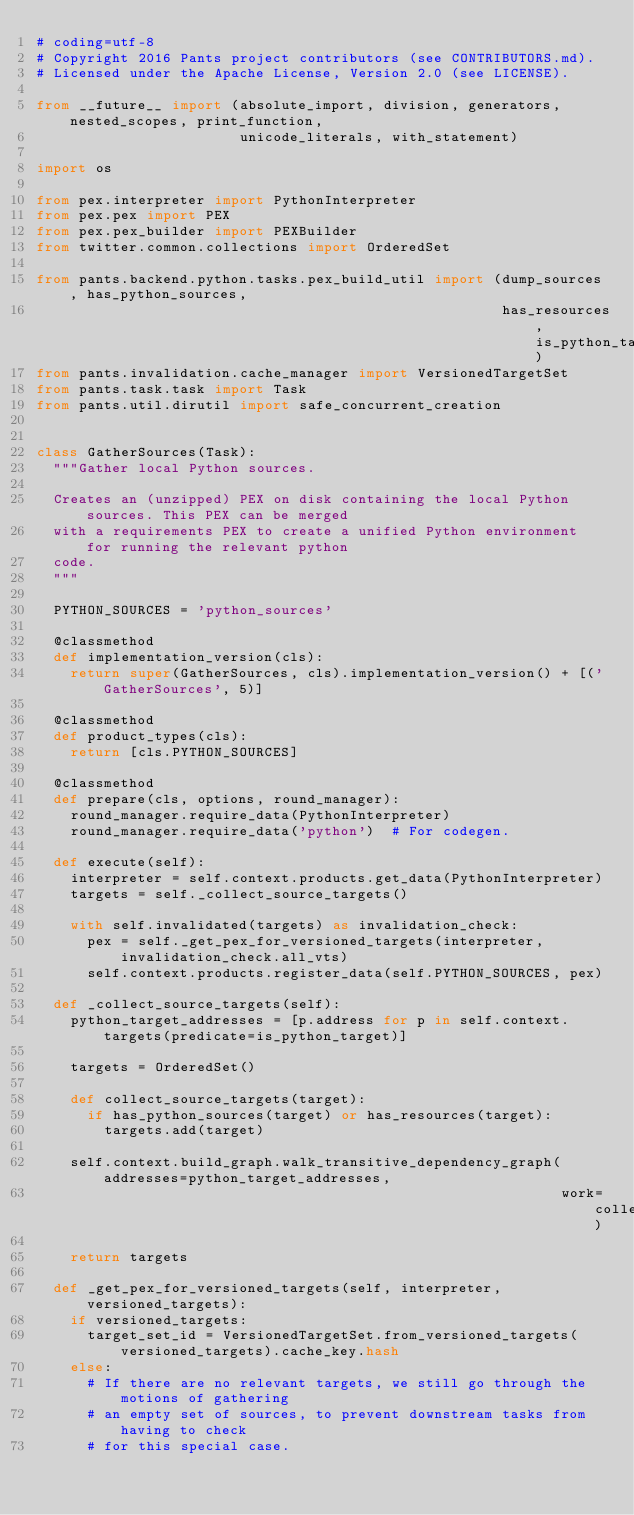Convert code to text. <code><loc_0><loc_0><loc_500><loc_500><_Python_># coding=utf-8
# Copyright 2016 Pants project contributors (see CONTRIBUTORS.md).
# Licensed under the Apache License, Version 2.0 (see LICENSE).

from __future__ import (absolute_import, division, generators, nested_scopes, print_function,
                        unicode_literals, with_statement)

import os

from pex.interpreter import PythonInterpreter
from pex.pex import PEX
from pex.pex_builder import PEXBuilder
from twitter.common.collections import OrderedSet

from pants.backend.python.tasks.pex_build_util import (dump_sources, has_python_sources,
                                                       has_resources, is_python_target)
from pants.invalidation.cache_manager import VersionedTargetSet
from pants.task.task import Task
from pants.util.dirutil import safe_concurrent_creation


class GatherSources(Task):
  """Gather local Python sources.

  Creates an (unzipped) PEX on disk containing the local Python sources. This PEX can be merged
  with a requirements PEX to create a unified Python environment for running the relevant python
  code.
  """

  PYTHON_SOURCES = 'python_sources'

  @classmethod
  def implementation_version(cls):
    return super(GatherSources, cls).implementation_version() + [('GatherSources', 5)]

  @classmethod
  def product_types(cls):
    return [cls.PYTHON_SOURCES]

  @classmethod
  def prepare(cls, options, round_manager):
    round_manager.require_data(PythonInterpreter)
    round_manager.require_data('python')  # For codegen.

  def execute(self):
    interpreter = self.context.products.get_data(PythonInterpreter)
    targets = self._collect_source_targets()

    with self.invalidated(targets) as invalidation_check:
      pex = self._get_pex_for_versioned_targets(interpreter, invalidation_check.all_vts)
      self.context.products.register_data(self.PYTHON_SOURCES, pex)

  def _collect_source_targets(self):
    python_target_addresses = [p.address for p in self.context.targets(predicate=is_python_target)]

    targets = OrderedSet()

    def collect_source_targets(target):
      if has_python_sources(target) or has_resources(target):
        targets.add(target)

    self.context.build_graph.walk_transitive_dependency_graph(addresses=python_target_addresses,
                                                              work=collect_source_targets)

    return targets

  def _get_pex_for_versioned_targets(self, interpreter, versioned_targets):
    if versioned_targets:
      target_set_id = VersionedTargetSet.from_versioned_targets(versioned_targets).cache_key.hash
    else:
      # If there are no relevant targets, we still go through the motions of gathering
      # an empty set of sources, to prevent downstream tasks from having to check
      # for this special case.</code> 